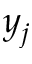Convert formula to latex. <formula><loc_0><loc_0><loc_500><loc_500>y _ { j }</formula> 